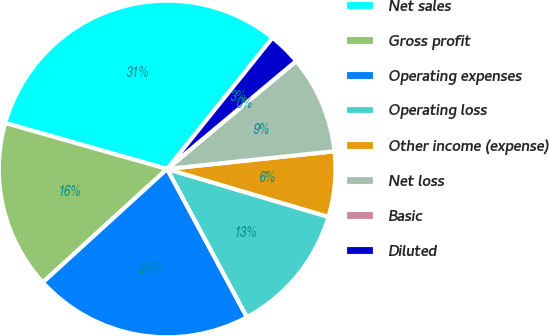Convert chart to OTSL. <chart><loc_0><loc_0><loc_500><loc_500><pie_chart><fcel>Net sales<fcel>Gross profit<fcel>Operating expenses<fcel>Operating loss<fcel>Other income (expense)<fcel>Net loss<fcel>Basic<fcel>Diluted<nl><fcel>31.37%<fcel>16.18%<fcel>21.09%<fcel>12.55%<fcel>6.27%<fcel>9.41%<fcel>0.0%<fcel>3.14%<nl></chart> 